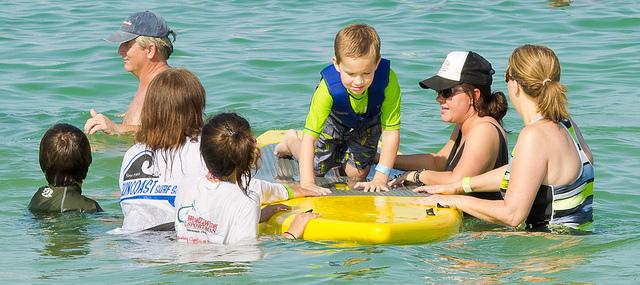What color is the little kids wristband?
Quick response, please. Blue. How many people are wearing hats?
Give a very brief answer. 2. Are they in a pool or open water?
Give a very brief answer. Open water. 